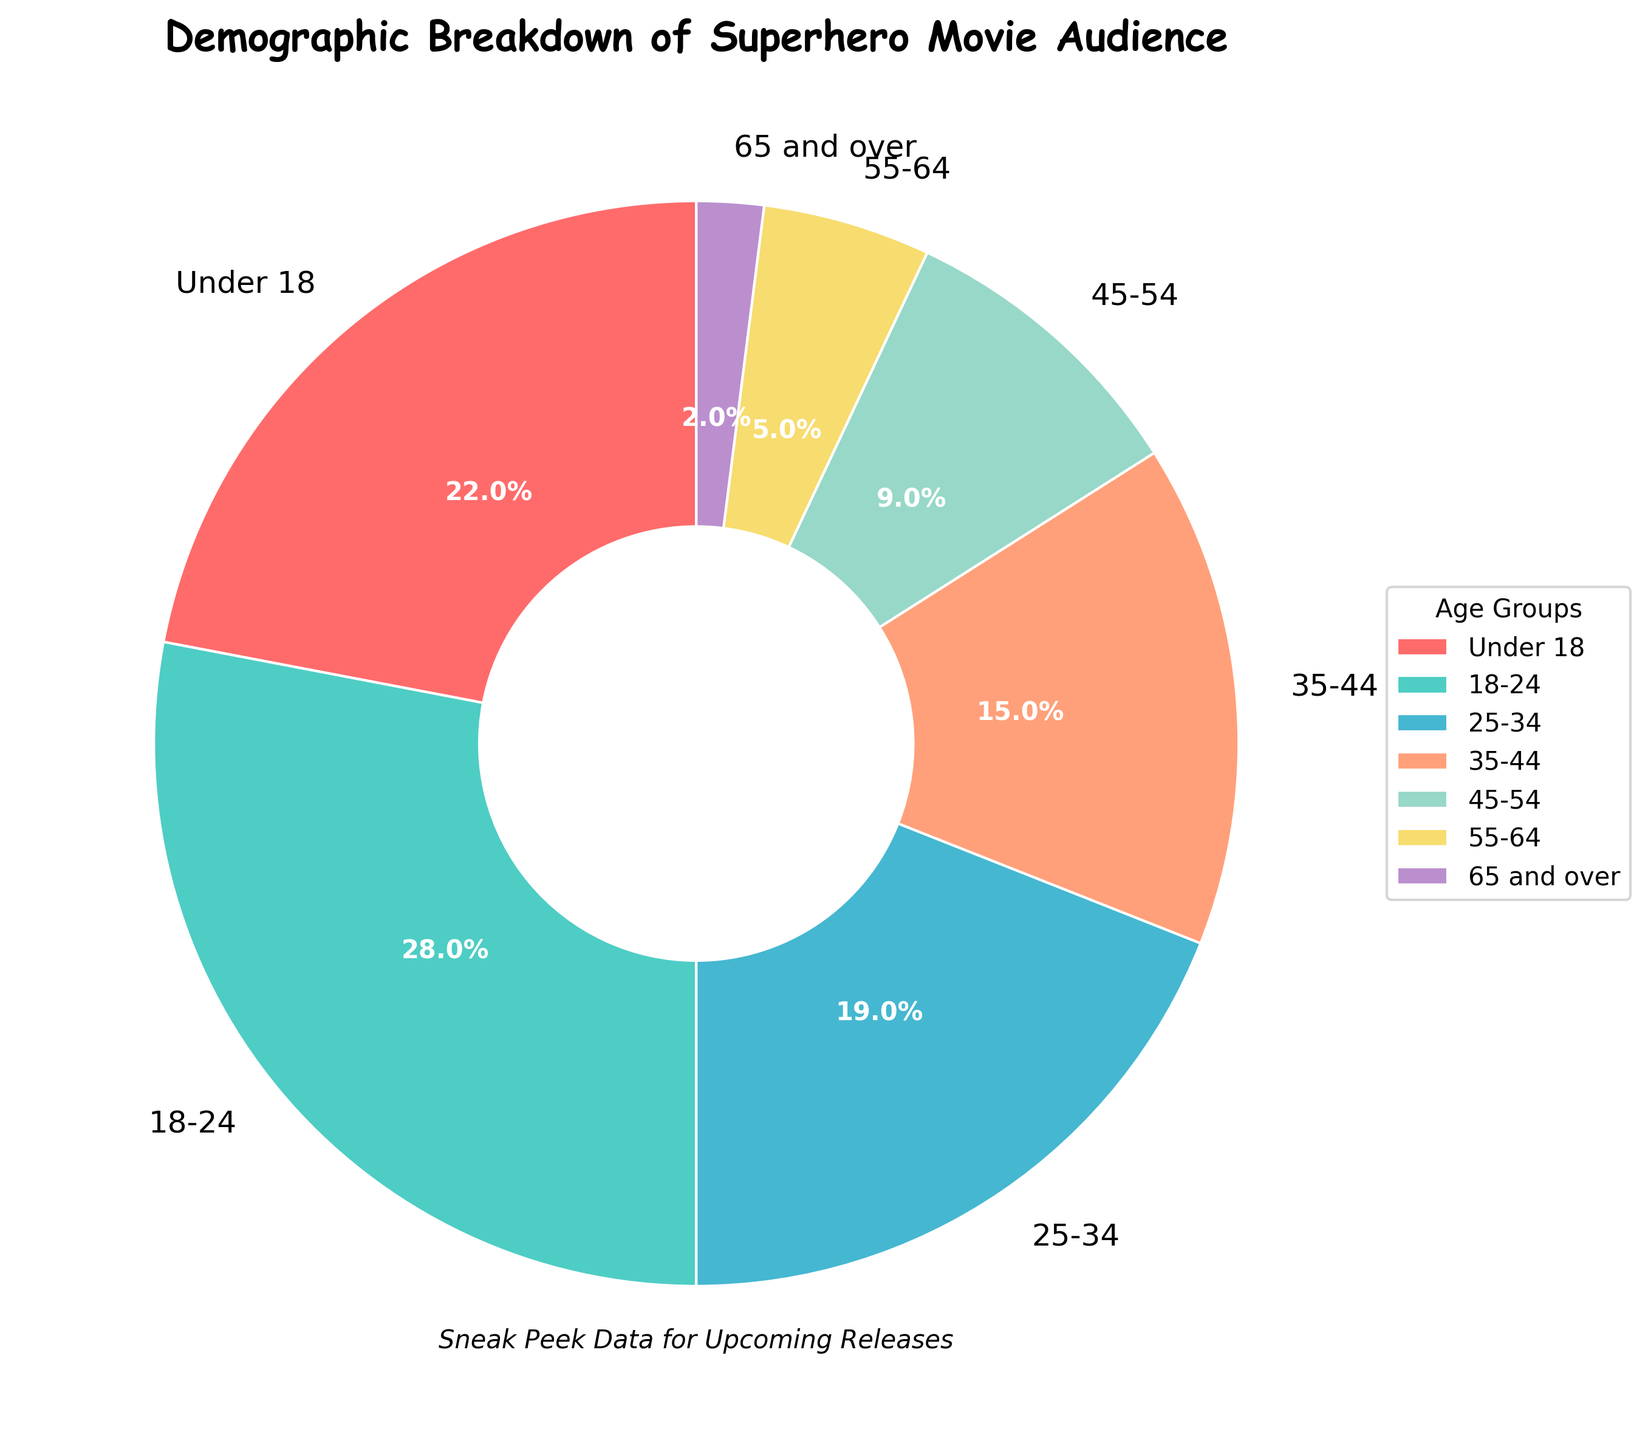which age group has the highest audience percentage? The pie chart displays audience percentages for various age groups. The segment labeled '18-24' has the highest percentage at 28%.
Answer: 18-24 what is the combined percentage of the audience aged 18 to 44 years? The percentage groups for 18 to 44 years are 18-24 (28%), 25-34 (19%), and 35-44 (15%). Adding these together: 28% + 19% + 15% = 62%.
Answer: 62% how much more percentage does the '18-24' age group have compared to the '65 and over' age group? The '18-24' age group has 28% and the '65 and over' age group has 2%. The difference is 28% - 2% = 26%.
Answer: 26% which age group has a smaller audience percentage: '25-34' or '55-64'? The percentages for '25-34' and '55-64' are 19% and 5%, respectively. Since 5% < 19%, the '55-64' age group has a smaller audience percentage.
Answer: 55-64 what percentage of the audience is older than 54 years? The age groups older than 54 years are '55-64' (5%) and '65 and over' (2%). Adding these together: 5% + 2% = 7%.
Answer: 7% what is the percentage difference between the '35-44' and '45-54' age groups? The percentages for '35-44' and '45-54' are 15% and 9%, respectively. The difference is 15% - 9% = 6%.
Answer: 6% how many age groups have an audience percentage greater than 20%? The age groups with audience percentages greater than 20% are 'Under 18' (22%) and '18-24' (28%). There are 2 such age groups.
Answer: 2 which color represents the '55-64' age group in the pie chart? Observing the pie chart, the segment for '55-64' is represented by a segment with light yellow-like color.
Answer: light yellow what is the sum of the audience percentages for the 'Under 18' and '45-54' age groups? The percentages for 'Under 18' and '45-54' are 22% and 9%, respectively. Adding these yields 22% + 9% = 31%.
Answer: 31% how does the audience percentage for '25-34' compare with '35-44'? The percentages for '25-34' and '35-44' are 19% and 15%, respectively. The '25-34' age group has a 4% higher audience percentage than the '35-44' age group.
Answer: 25-34 > 35-44 